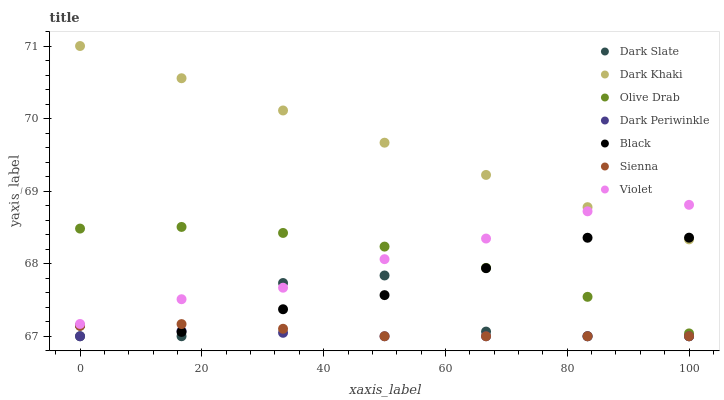Does Dark Periwinkle have the minimum area under the curve?
Answer yes or no. Yes. Does Dark Khaki have the maximum area under the curve?
Answer yes or no. Yes. Does Dark Slate have the minimum area under the curve?
Answer yes or no. No. Does Dark Slate have the maximum area under the curve?
Answer yes or no. No. Is Dark Khaki the smoothest?
Answer yes or no. Yes. Is Dark Slate the roughest?
Answer yes or no. Yes. Is Dark Slate the smoothest?
Answer yes or no. No. Is Dark Khaki the roughest?
Answer yes or no. No. Does Sienna have the lowest value?
Answer yes or no. Yes. Does Dark Khaki have the lowest value?
Answer yes or no. No. Does Dark Khaki have the highest value?
Answer yes or no. Yes. Does Dark Slate have the highest value?
Answer yes or no. No. Is Olive Drab less than Dark Khaki?
Answer yes or no. Yes. Is Violet greater than Dark Periwinkle?
Answer yes or no. Yes. Does Olive Drab intersect Violet?
Answer yes or no. Yes. Is Olive Drab less than Violet?
Answer yes or no. No. Is Olive Drab greater than Violet?
Answer yes or no. No. Does Olive Drab intersect Dark Khaki?
Answer yes or no. No. 